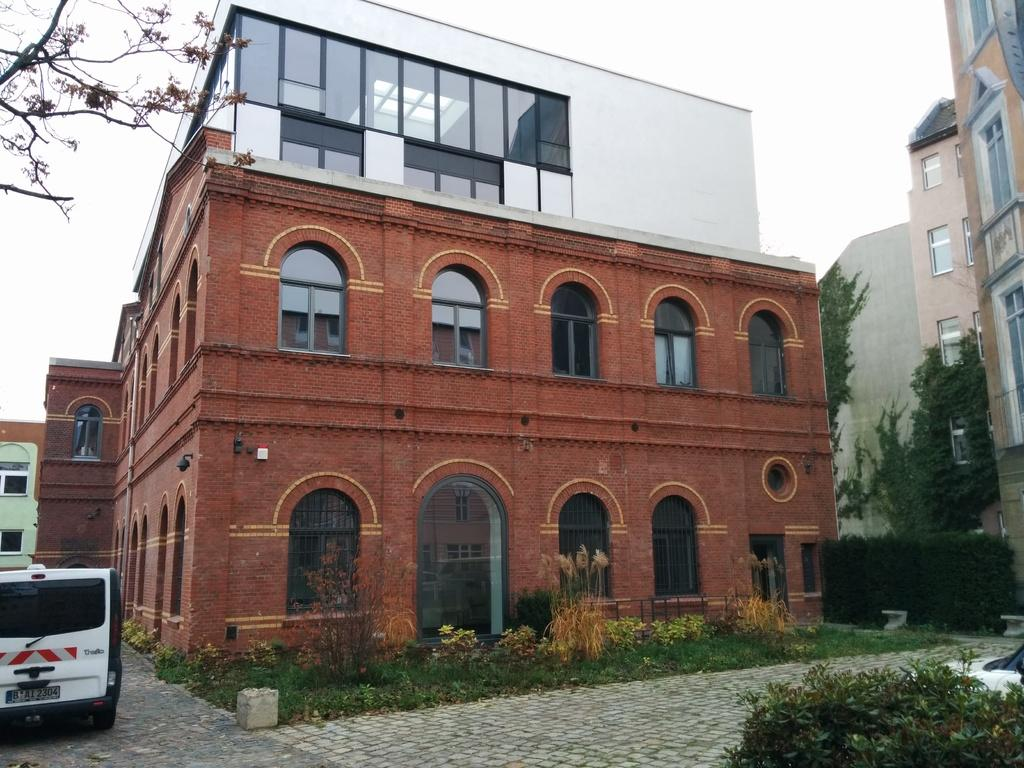What colors are used for the buildings in the image? The buildings in the image are in brown, cream, and white colors. What type of vehicle can be seen in the image? There is a white-colored vehicle in the image. What color are the trees in the image? The trees in the image are in green color. What is visible in the background of the image? The sky is visible in the image and appears to be white. How many snakes are slithering on the earth in the image? There are no snakes present in the image; it features buildings, a vehicle, trees, and a white sky. What type of attention is the image trying to draw from the viewer? The image is not trying to draw any specific type of attention from the viewer; it is simply a representation of the scene. 